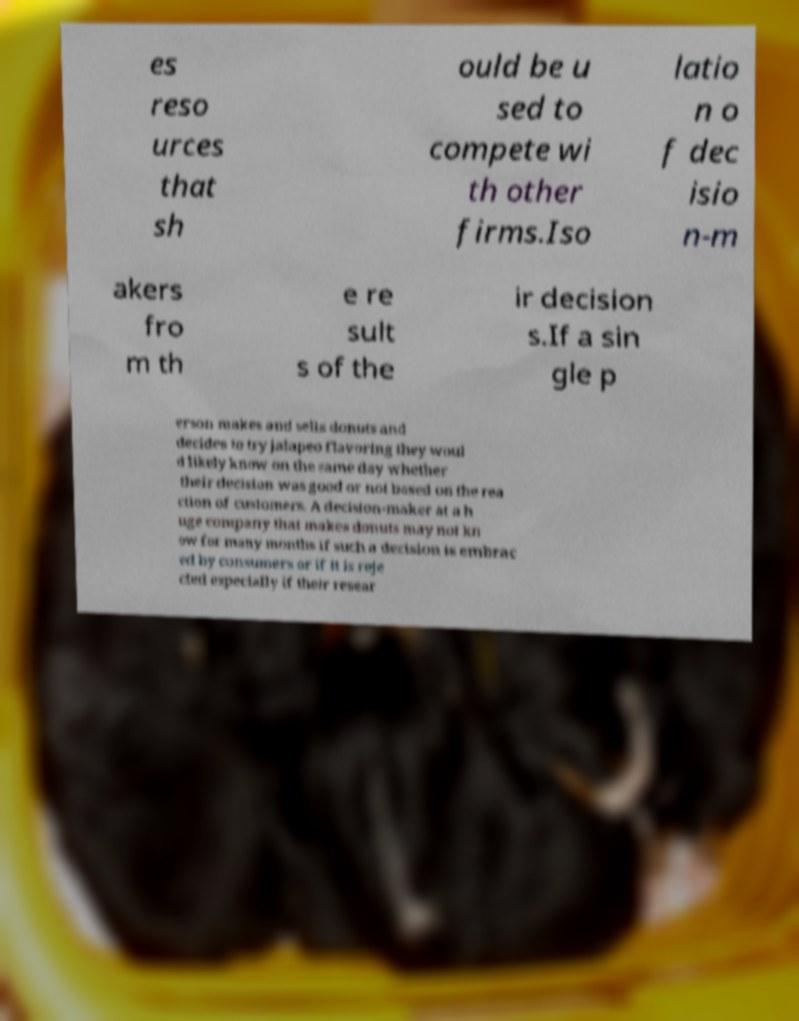Could you extract and type out the text from this image? es reso urces that sh ould be u sed to compete wi th other firms.Iso latio n o f dec isio n-m akers fro m th e re sult s of the ir decision s.If a sin gle p erson makes and sells donuts and decides to try jalapeo flavoring they woul d likely know on the same day whether their decision was good or not based on the rea ction of customers. A decision-maker at a h uge company that makes donuts may not kn ow for many months if such a decision is embrac ed by consumers or if it is reje cted especially if their resear 